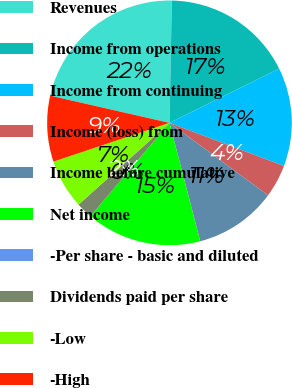Convert chart to OTSL. <chart><loc_0><loc_0><loc_500><loc_500><pie_chart><fcel>Revenues<fcel>Income from operations<fcel>Income from continuing<fcel>Income (loss) from<fcel>Income before cumulative<fcel>Net income<fcel>-Per share - basic and diluted<fcel>Dividends paid per share<fcel>-Low<fcel>-High<nl><fcel>21.74%<fcel>17.39%<fcel>13.04%<fcel>4.35%<fcel>10.87%<fcel>15.22%<fcel>0.0%<fcel>2.17%<fcel>6.52%<fcel>8.7%<nl></chart> 